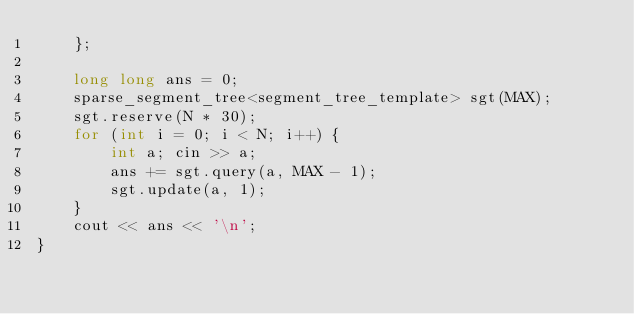Convert code to text. <code><loc_0><loc_0><loc_500><loc_500><_C++_>	};

	long long ans = 0;
	sparse_segment_tree<segment_tree_template> sgt(MAX);
	sgt.reserve(N * 30);
	for (int i = 0; i < N; i++) {
		int a; cin >> a;
		ans += sgt.query(a, MAX - 1);
		sgt.update(a, 1);
	}
	cout << ans << '\n';
}</code> 